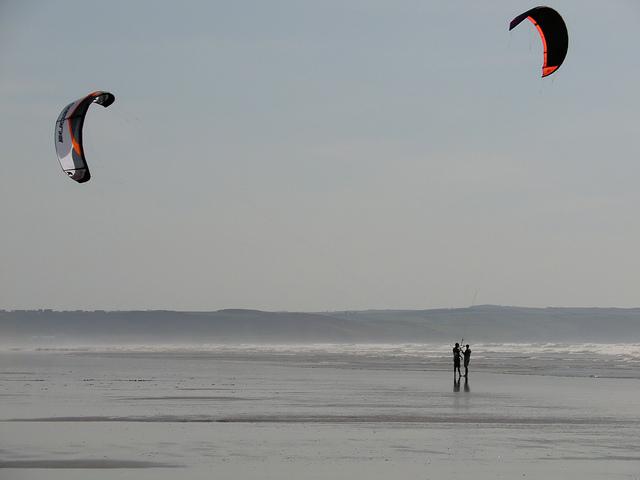How many people are in the water?
Be succinct. 2. How many people are visible?
Answer briefly. 2. What are the objects in the sky?
Give a very brief answer. Kites. Is it foggy?
Write a very short answer. No. 